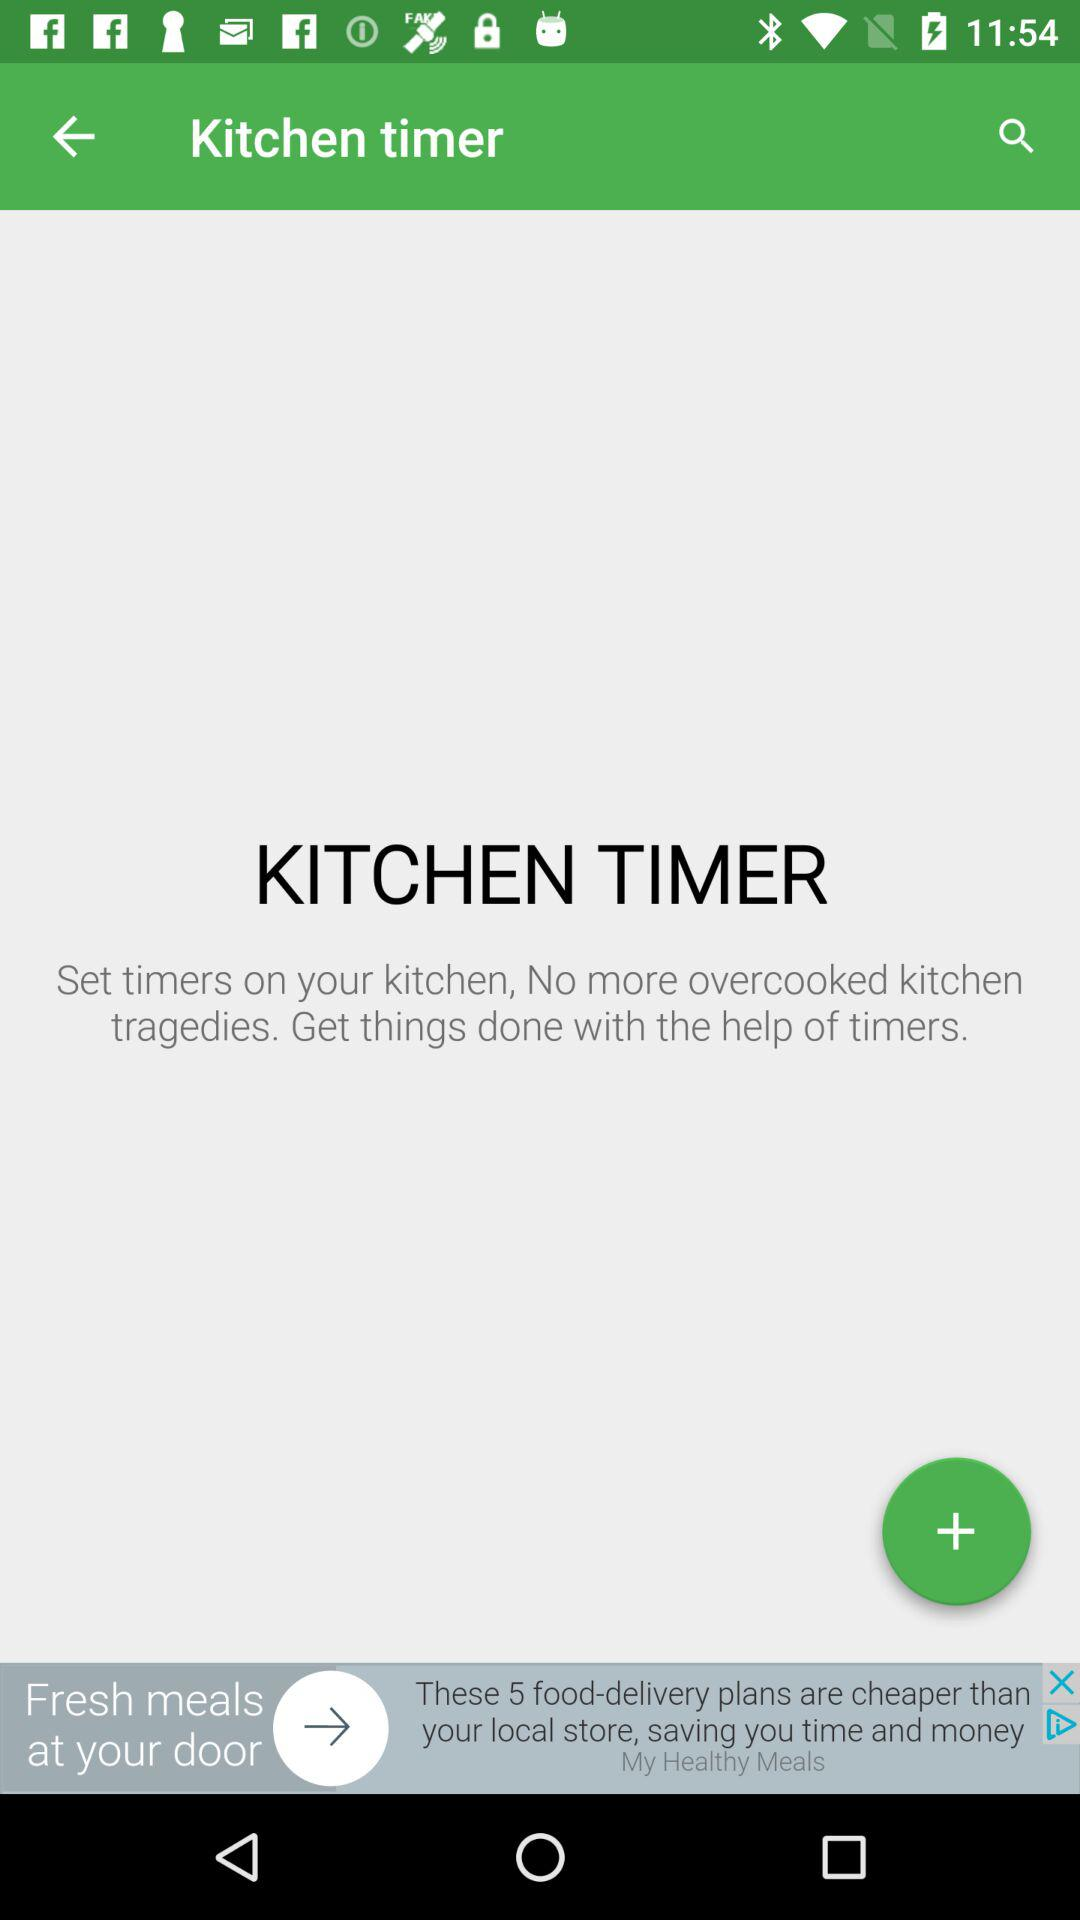What is the application name? The application name is "Kitchen timer". 